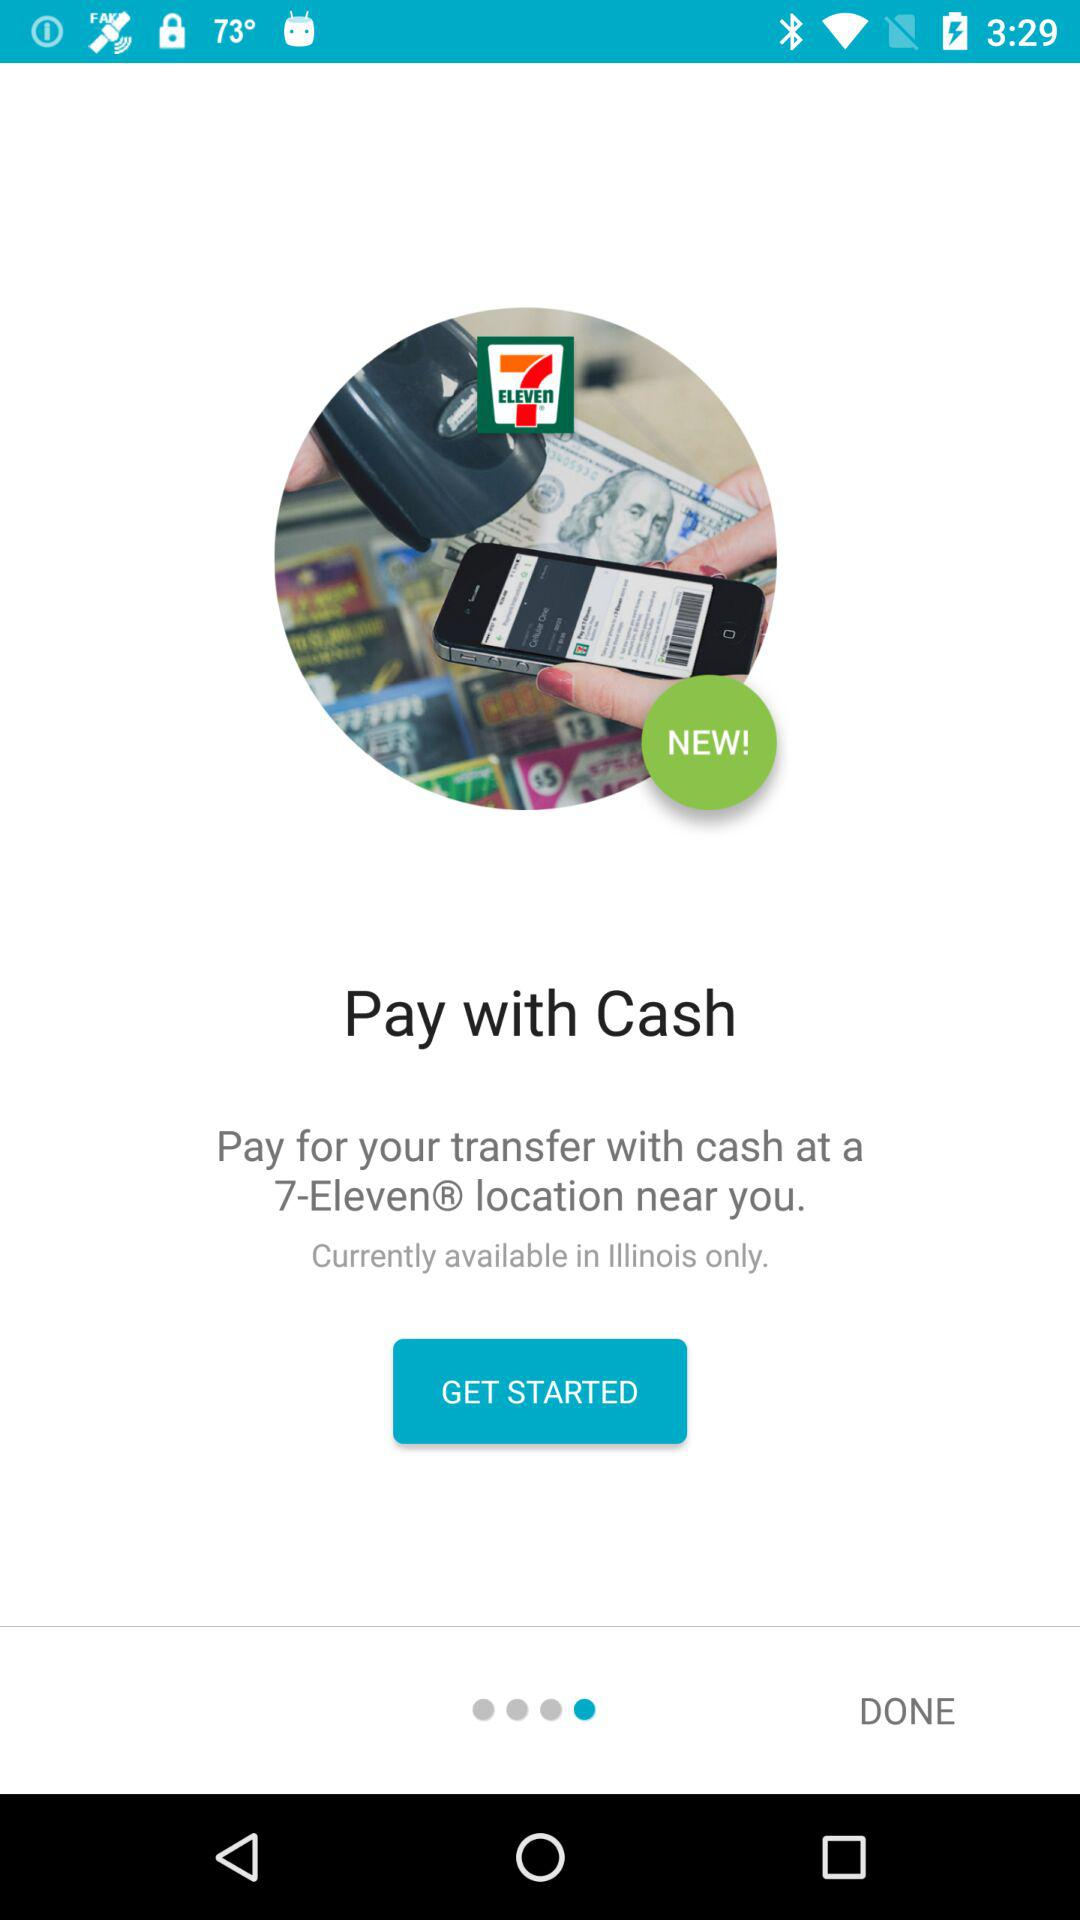What is the application name? The application name is "7-Eleven". 